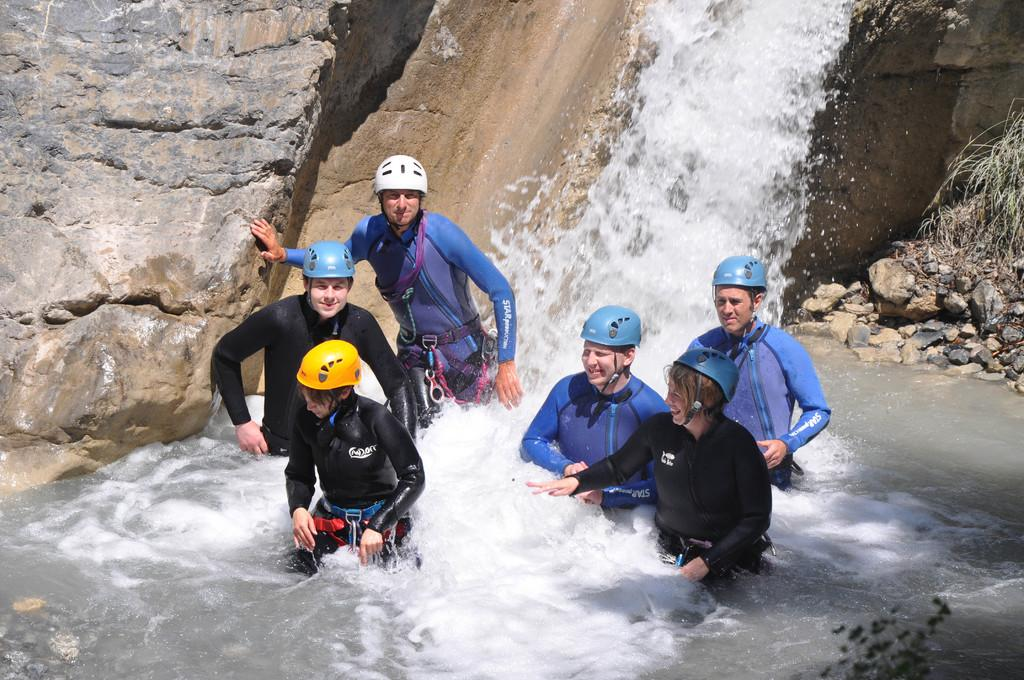What natural feature is the main subject of the image? There is a waterfall in the image. What are the people at the bottom of the waterfall doing? People are standing at the bottom of the waterfall. What can be seen in the water in the background of the image? There are rocks in the water in the background of the image. Can you see any forks or toys near the waterfall in the image? No, there are no forks or toys present in the image. 